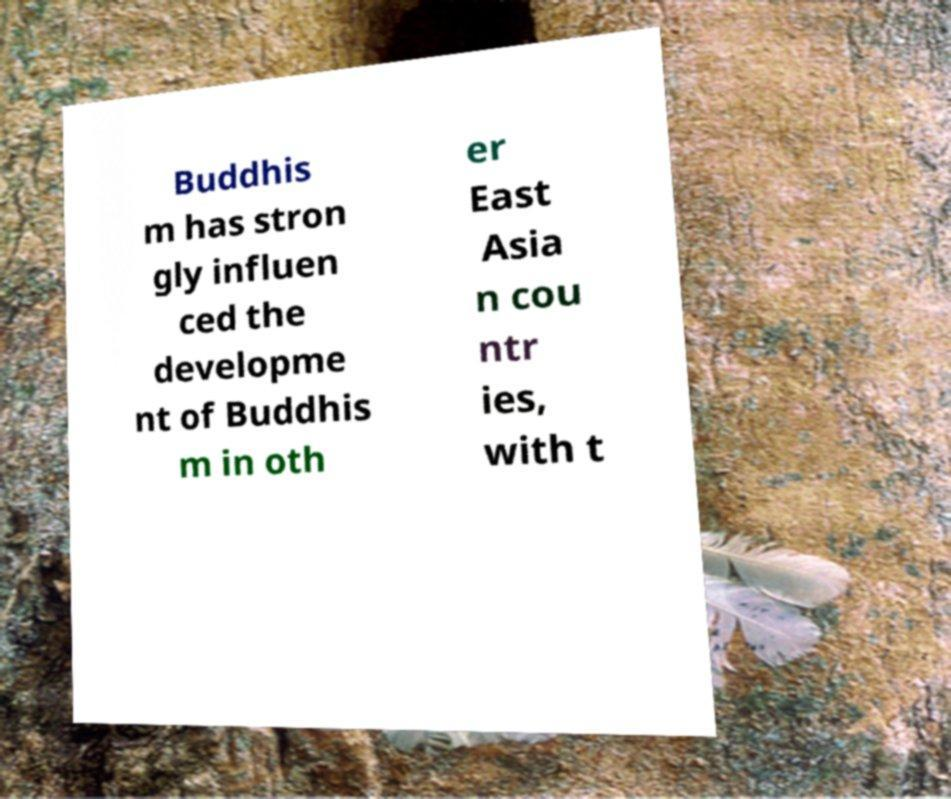Can you read and provide the text displayed in the image?This photo seems to have some interesting text. Can you extract and type it out for me? Buddhis m has stron gly influen ced the developme nt of Buddhis m in oth er East Asia n cou ntr ies, with t 